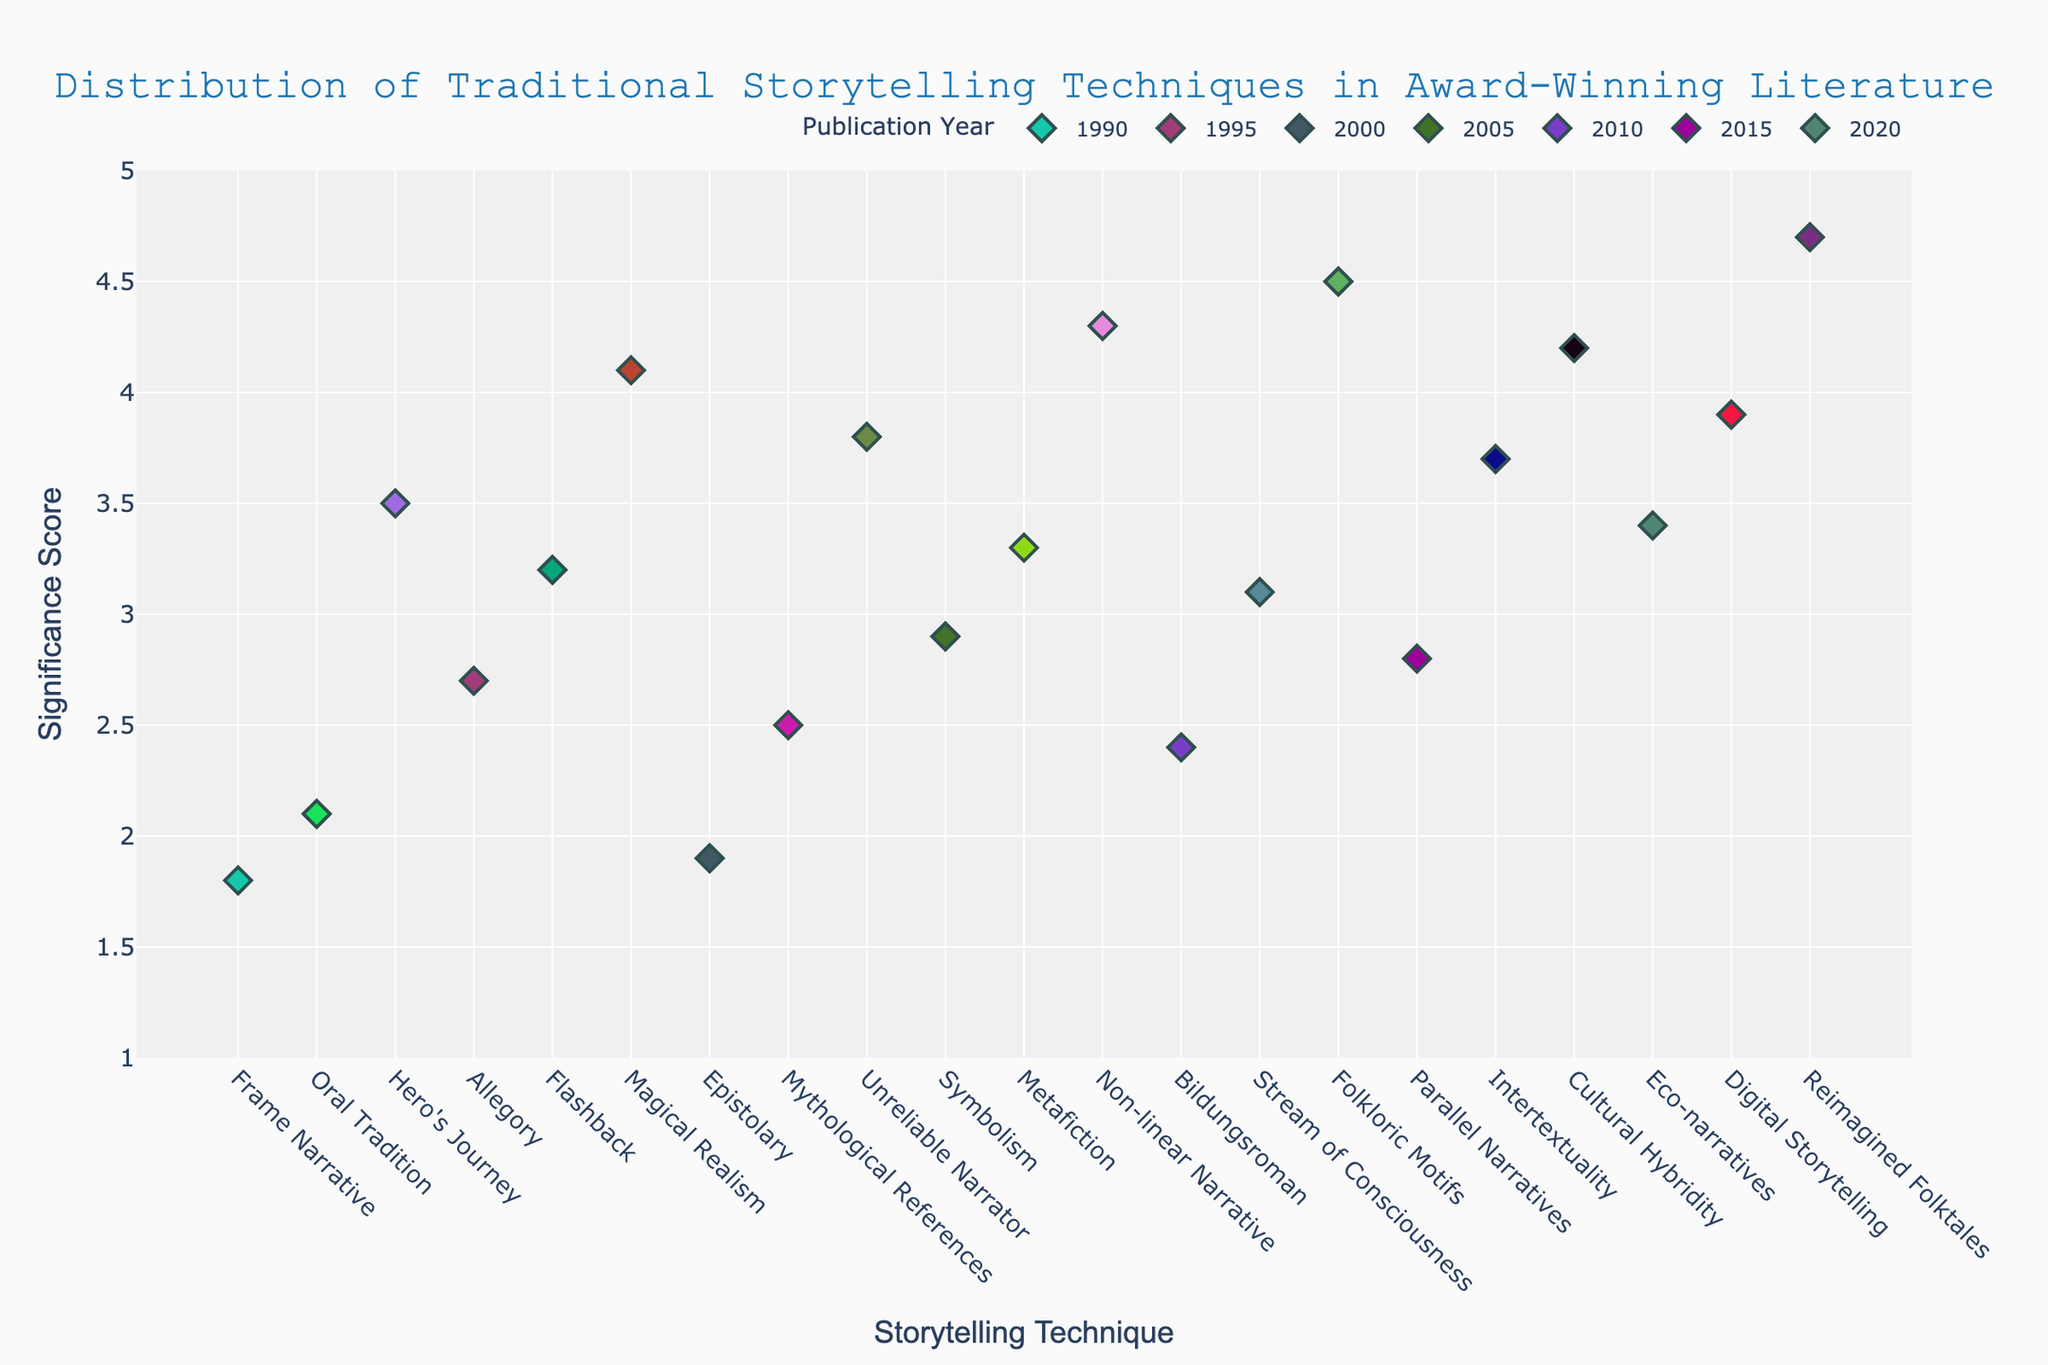What's the title of the figure? The title of the figure is prominently displayed at the top of the plot.
Answer: Distribution of Traditional Storytelling Techniques in Award-Winning Literature What is the maximum significance score recorded in the year 2020? To find the maximum significance score for the year 2020, look at the colored points labeled with the respective techniques for that year. The highest point in the 2020 subset shows a score of 4.7.
Answer: 4.7 Which storytelling technique has the highest significance score in 2010? For the year 2010, check the points corresponding to each storytelling technique. The technique with the highest vertical position, indicating the highest score, is 'Folkloric Motifs' with a score of 4.5.
Answer: Folkloric Motifs How many different storytelling techniques are displayed for the year 2005? Count the distinct storytelling technique labels on the x-axis that correspond to points plotted for the year 2005. There are three such techniques.
Answer: 3 What is the significance score range used on the y-axis? The range for the y-axis can be seen in the labeled values along it. They range from 1 to 5.
Answer: 1 to 5 Which year has the most storytelling techniques plotted? Compare the number of distinct techniques plotted for each year. The year with the most distinct storytelling techniques is 2020.
Answer: 2020 In which year and for which technique does the lowest significance score occur? Identify the point placed closest to the bottom of the y-axis. This point represents the lowest significance score; it's for 'Frame Narrative' in the year 1990 with a score of 1.8.
Answer: 1990, Frame Narrative What is the average significance score of techniques in 2015? Sum the significance scores for 2015 and divide by the number of techniques. (3.7 + 2.8 + 4.2) / 3 = 3.57.
Answer: 3.57 Between 1995 and 2005, which year has a higher overall maximum significance score? Compare the maximum scores for the years 1995 (4.1) and 2005 (4.3). The highest maximum score is in 2005.
Answer: 2005 Is there a storytelling technique that appears in both 1990 and 2020? Check if any of the techniques listed for 1990 also appear in 2020. There are no overlapping techniques.
Answer: No What is the difference between the highest and the lowest significance scores in the year 2000? Find the highest (3.8) and the lowest (1.9) scores in 2000 and calculate their difference: 3.8 - 1.9 = 1.9.
Answer: 1.9 